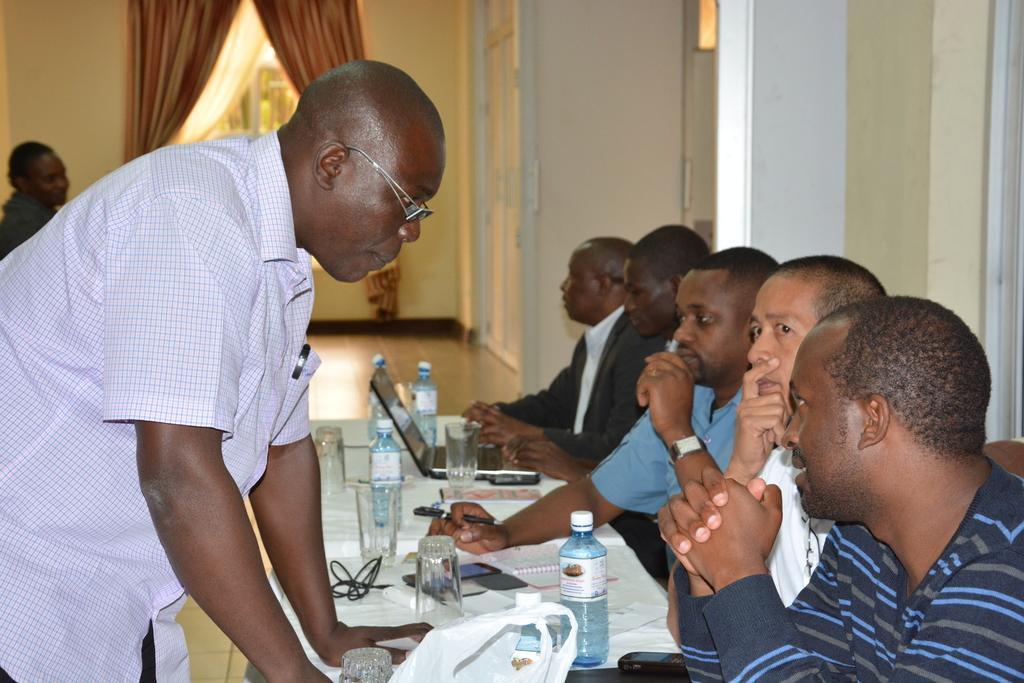Could you give a brief overview of what you see in this image? As we can see in the image there is wall, window, curtains, group of people, chairs and table. On table there are bottles, glasses, laptop, wires, mobile phone and white color cloth. 